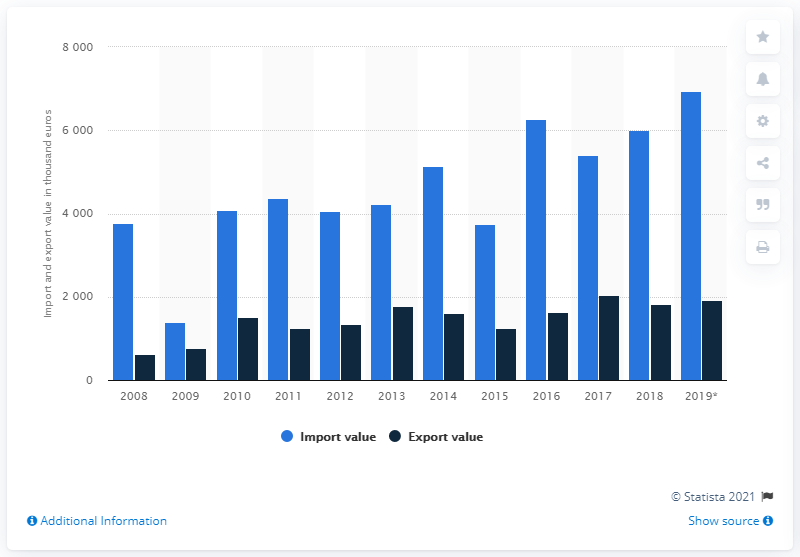Specify some key components in this picture. In 2008, the import and export of citrus and melon peel between the Netherlands and other countries began. 